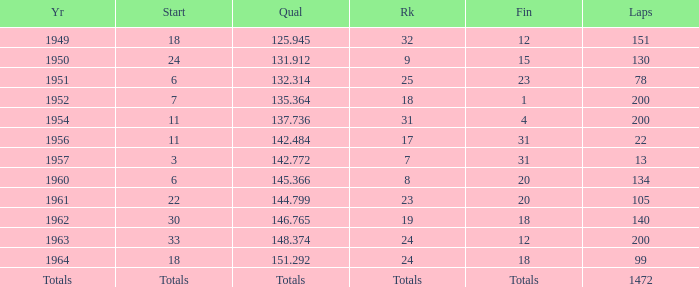Name the rank with finish of 12 and year of 1963 24.0. 